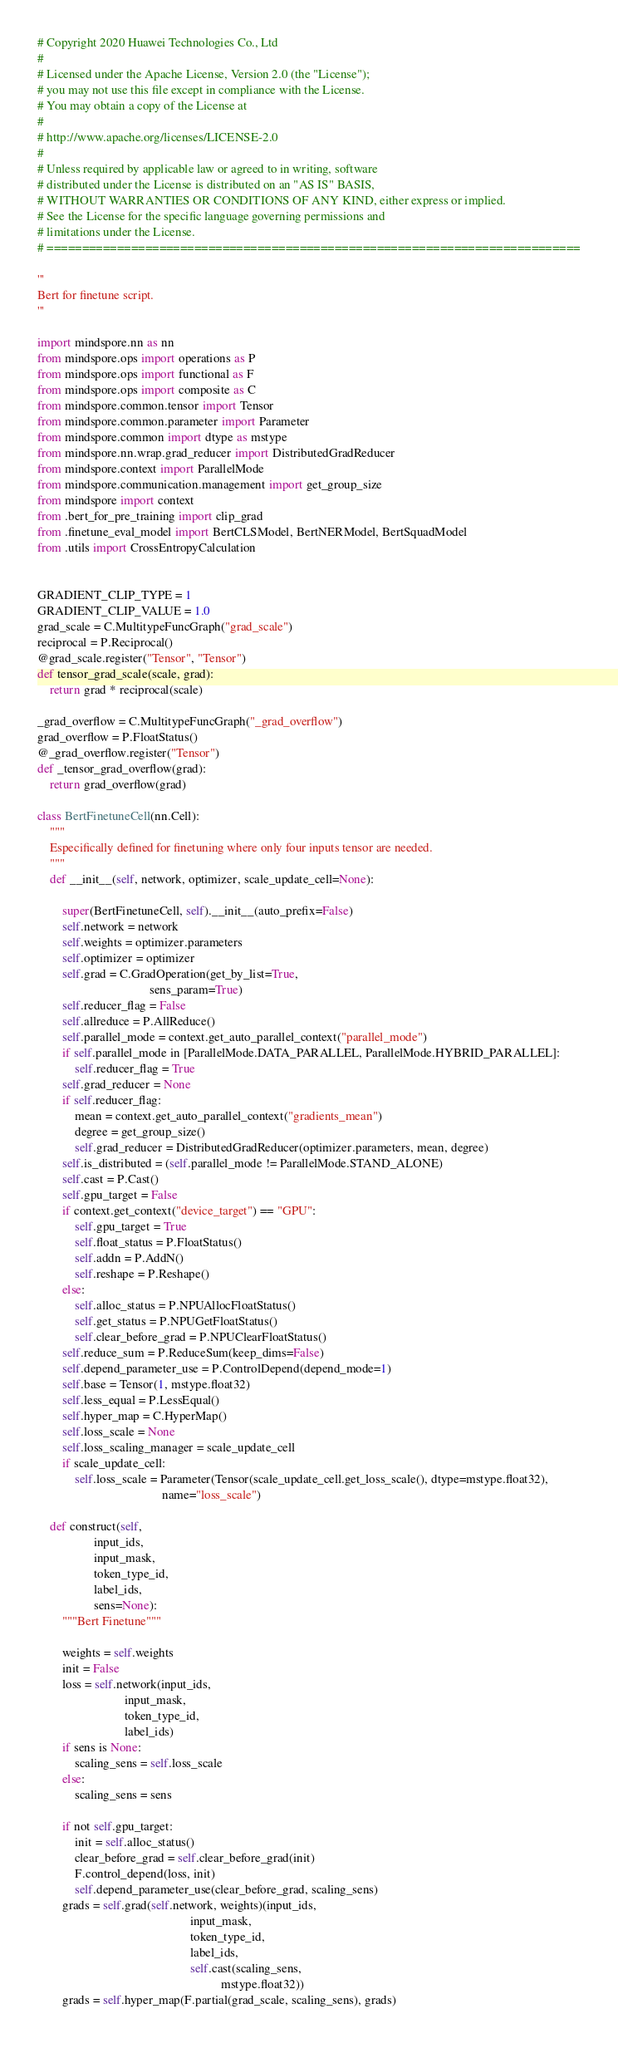Convert code to text. <code><loc_0><loc_0><loc_500><loc_500><_Python_># Copyright 2020 Huawei Technologies Co., Ltd
#
# Licensed under the Apache License, Version 2.0 (the "License");
# you may not use this file except in compliance with the License.
# You may obtain a copy of the License at
#
# http://www.apache.org/licenses/LICENSE-2.0
#
# Unless required by applicable law or agreed to in writing, software
# distributed under the License is distributed on an "AS IS" BASIS,
# WITHOUT WARRANTIES OR CONDITIONS OF ANY KIND, either express or implied.
# See the License for the specific language governing permissions and
# limitations under the License.
# ============================================================================

'''
Bert for finetune script.
'''

import mindspore.nn as nn
from mindspore.ops import operations as P
from mindspore.ops import functional as F
from mindspore.ops import composite as C
from mindspore.common.tensor import Tensor
from mindspore.common.parameter import Parameter
from mindspore.common import dtype as mstype
from mindspore.nn.wrap.grad_reducer import DistributedGradReducer
from mindspore.context import ParallelMode
from mindspore.communication.management import get_group_size
from mindspore import context
from .bert_for_pre_training import clip_grad
from .finetune_eval_model import BertCLSModel, BertNERModel, BertSquadModel
from .utils import CrossEntropyCalculation


GRADIENT_CLIP_TYPE = 1
GRADIENT_CLIP_VALUE = 1.0
grad_scale = C.MultitypeFuncGraph("grad_scale")
reciprocal = P.Reciprocal()
@grad_scale.register("Tensor", "Tensor")
def tensor_grad_scale(scale, grad):
    return grad * reciprocal(scale)

_grad_overflow = C.MultitypeFuncGraph("_grad_overflow")
grad_overflow = P.FloatStatus()
@_grad_overflow.register("Tensor")
def _tensor_grad_overflow(grad):
    return grad_overflow(grad)

class BertFinetuneCell(nn.Cell):
    """
    Especifically defined for finetuning where only four inputs tensor are needed.
    """
    def __init__(self, network, optimizer, scale_update_cell=None):

        super(BertFinetuneCell, self).__init__(auto_prefix=False)
        self.network = network
        self.weights = optimizer.parameters
        self.optimizer = optimizer
        self.grad = C.GradOperation(get_by_list=True,
                                    sens_param=True)
        self.reducer_flag = False
        self.allreduce = P.AllReduce()
        self.parallel_mode = context.get_auto_parallel_context("parallel_mode")
        if self.parallel_mode in [ParallelMode.DATA_PARALLEL, ParallelMode.HYBRID_PARALLEL]:
            self.reducer_flag = True
        self.grad_reducer = None
        if self.reducer_flag:
            mean = context.get_auto_parallel_context("gradients_mean")
            degree = get_group_size()
            self.grad_reducer = DistributedGradReducer(optimizer.parameters, mean, degree)
        self.is_distributed = (self.parallel_mode != ParallelMode.STAND_ALONE)
        self.cast = P.Cast()
        self.gpu_target = False
        if context.get_context("device_target") == "GPU":
            self.gpu_target = True
            self.float_status = P.FloatStatus()
            self.addn = P.AddN()
            self.reshape = P.Reshape()
        else:
            self.alloc_status = P.NPUAllocFloatStatus()
            self.get_status = P.NPUGetFloatStatus()
            self.clear_before_grad = P.NPUClearFloatStatus()
        self.reduce_sum = P.ReduceSum(keep_dims=False)
        self.depend_parameter_use = P.ControlDepend(depend_mode=1)
        self.base = Tensor(1, mstype.float32)
        self.less_equal = P.LessEqual()
        self.hyper_map = C.HyperMap()
        self.loss_scale = None
        self.loss_scaling_manager = scale_update_cell
        if scale_update_cell:
            self.loss_scale = Parameter(Tensor(scale_update_cell.get_loss_scale(), dtype=mstype.float32),
                                        name="loss_scale")

    def construct(self,
                  input_ids,
                  input_mask,
                  token_type_id,
                  label_ids,
                  sens=None):
        """Bert Finetune"""

        weights = self.weights
        init = False
        loss = self.network(input_ids,
                            input_mask,
                            token_type_id,
                            label_ids)
        if sens is None:
            scaling_sens = self.loss_scale
        else:
            scaling_sens = sens

        if not self.gpu_target:
            init = self.alloc_status()
            clear_before_grad = self.clear_before_grad(init)
            F.control_depend(loss, init)
            self.depend_parameter_use(clear_before_grad, scaling_sens)
        grads = self.grad(self.network, weights)(input_ids,
                                                 input_mask,
                                                 token_type_id,
                                                 label_ids,
                                                 self.cast(scaling_sens,
                                                           mstype.float32))
        grads = self.hyper_map(F.partial(grad_scale, scaling_sens), grads)</code> 